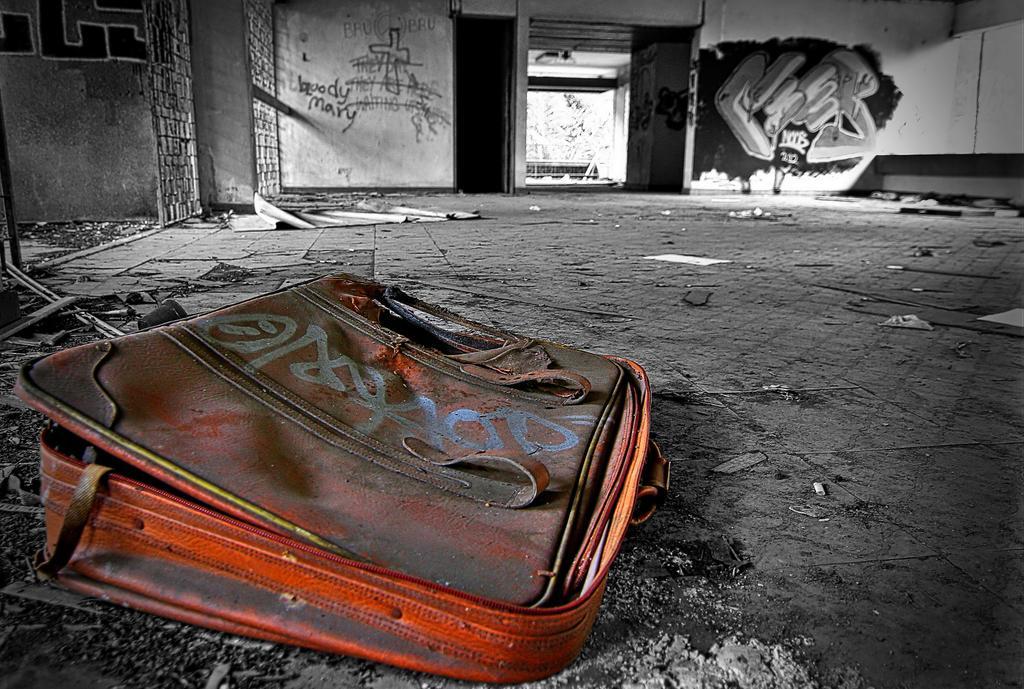Describe this image in one or two sentences. In this image there is a bag with full of dust and in back ground there is gate , wall , paintings, tree, shed , papers. 